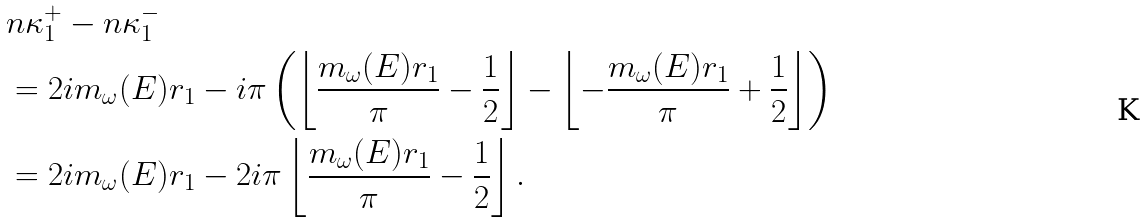Convert formula to latex. <formula><loc_0><loc_0><loc_500><loc_500>& \L n \kappa _ { 1 } ^ { + } - \L n \kappa _ { 1 } ^ { - } \\ & = 2 i m _ { \omega } ( E ) r _ { 1 } - i \pi \left ( \left \lfloor \frac { m _ { \omega } ( E ) r _ { 1 } } { \pi } - \frac { 1 } { 2 } \right \rfloor - \left \lfloor - \frac { m _ { \omega } ( E ) r _ { 1 } } { \pi } + \frac { 1 } { 2 } \right \rfloor \right ) \\ & = 2 i m _ { \omega } ( E ) r _ { 1 } - 2 i \pi \left \lfloor \frac { m _ { \omega } ( E ) r _ { 1 } } { \pi } - \frac { 1 } { 2 } \right \rfloor .</formula> 